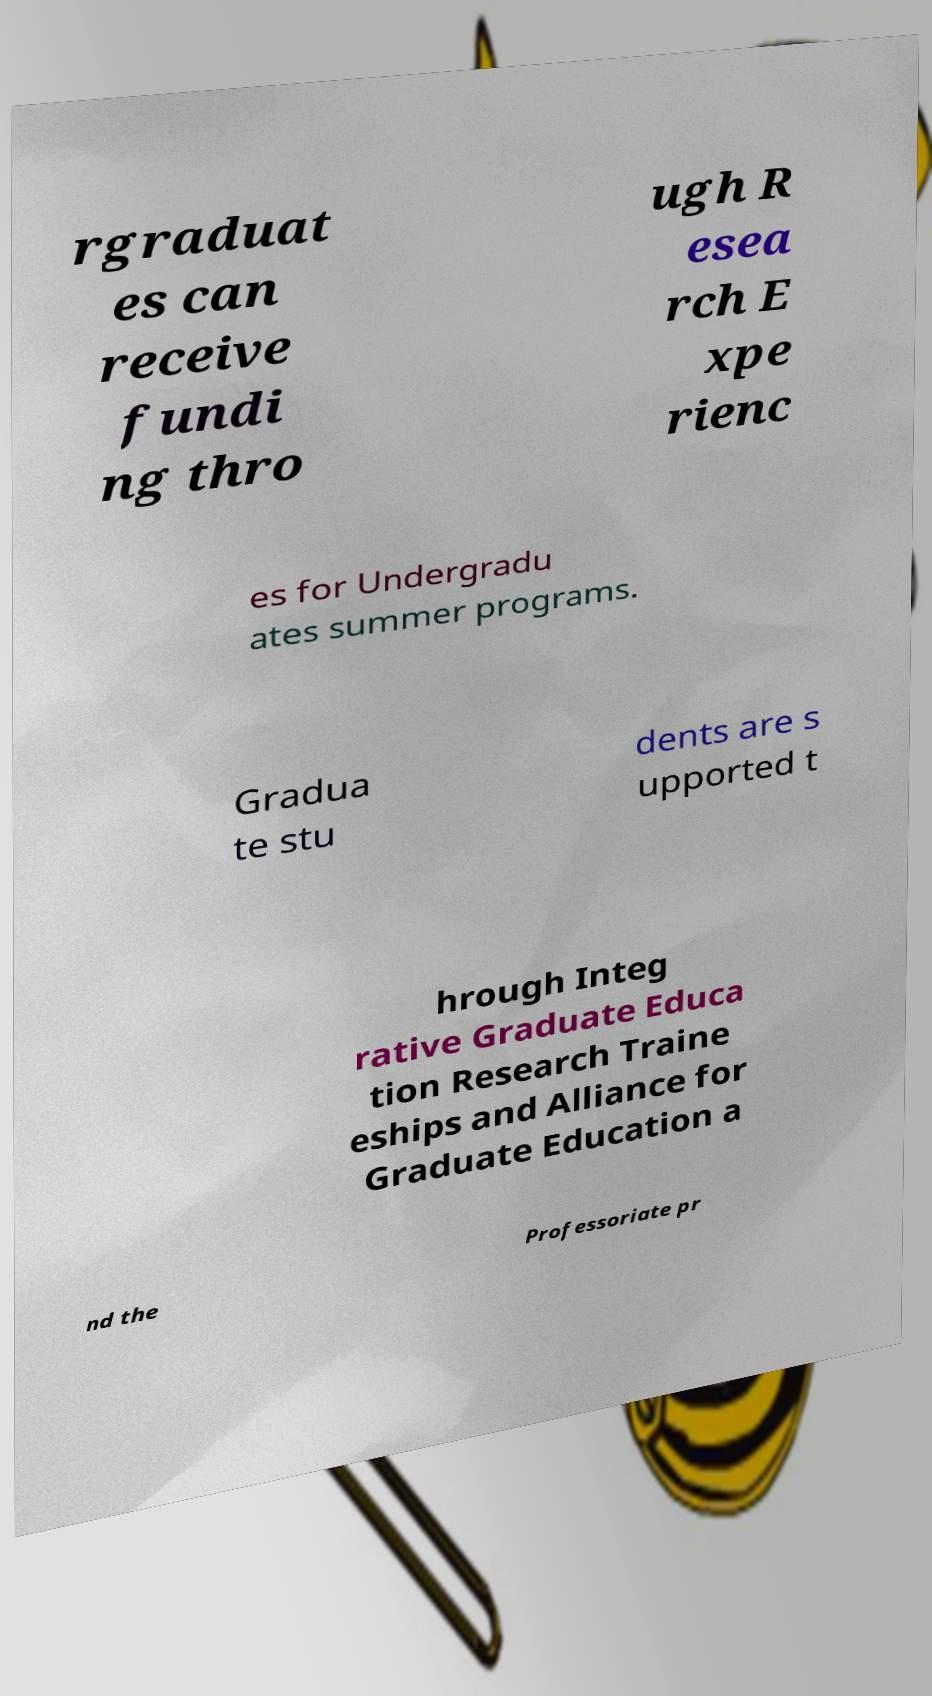Please identify and transcribe the text found in this image. rgraduat es can receive fundi ng thro ugh R esea rch E xpe rienc es for Undergradu ates summer programs. Gradua te stu dents are s upported t hrough Integ rative Graduate Educa tion Research Traine eships and Alliance for Graduate Education a nd the Professoriate pr 